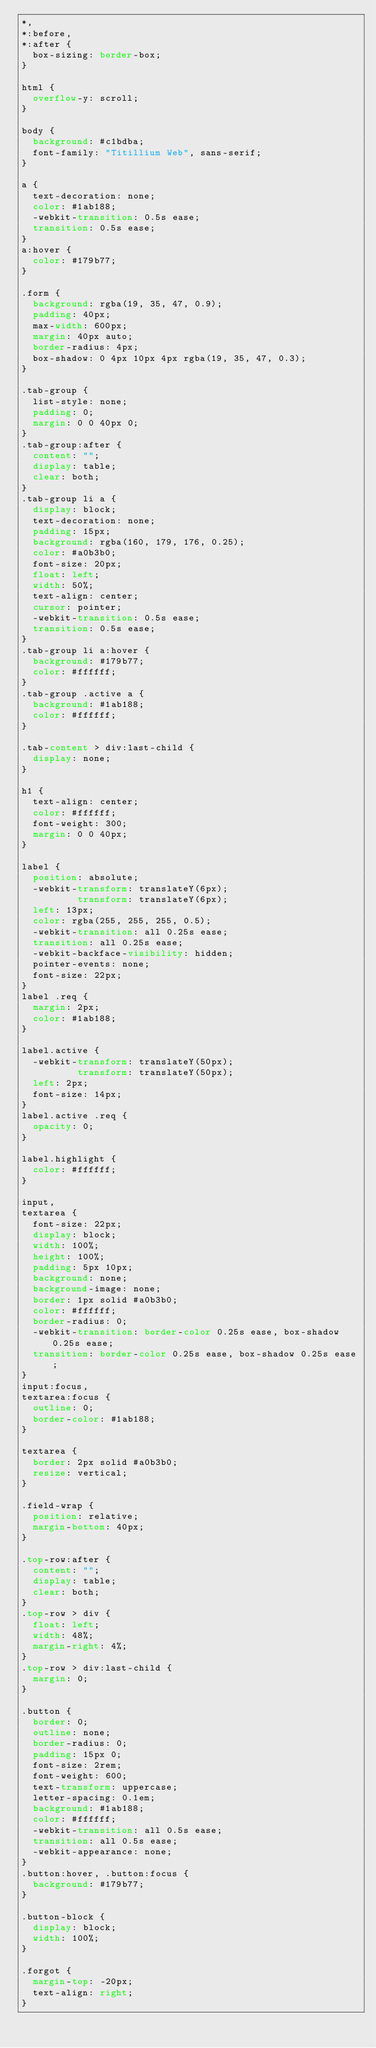Convert code to text. <code><loc_0><loc_0><loc_500><loc_500><_CSS_>*,
*:before,
*:after {
  box-sizing: border-box;
}

html {
  overflow-y: scroll;
}

body {
  background: #c1bdba;
  font-family: "Titillium Web", sans-serif;
}

a {
  text-decoration: none;
  color: #1ab188;
  -webkit-transition: 0.5s ease;
  transition: 0.5s ease;
}
a:hover {
  color: #179b77;
}

.form {
  background: rgba(19, 35, 47, 0.9);
  padding: 40px;
  max-width: 600px;
  margin: 40px auto;
  border-radius: 4px;
  box-shadow: 0 4px 10px 4px rgba(19, 35, 47, 0.3);
}

.tab-group {
  list-style: none;
  padding: 0;
  margin: 0 0 40px 0;
}
.tab-group:after {
  content: "";
  display: table;
  clear: both;
}
.tab-group li a {
  display: block;
  text-decoration: none;
  padding: 15px;
  background: rgba(160, 179, 176, 0.25);
  color: #a0b3b0;
  font-size: 20px;
  float: left;
  width: 50%;
  text-align: center;
  cursor: pointer;
  -webkit-transition: 0.5s ease;
  transition: 0.5s ease;
}
.tab-group li a:hover {
  background: #179b77;
  color: #ffffff;
}
.tab-group .active a {
  background: #1ab188;
  color: #ffffff;
}

.tab-content > div:last-child {
  display: none;
}

h1 {
  text-align: center;
  color: #ffffff;
  font-weight: 300;
  margin: 0 0 40px;
}

label {
  position: absolute;
  -webkit-transform: translateY(6px);
          transform: translateY(6px);
  left: 13px;
  color: rgba(255, 255, 255, 0.5);
  -webkit-transition: all 0.25s ease;
  transition: all 0.25s ease;
  -webkit-backface-visibility: hidden;
  pointer-events: none;
  font-size: 22px;
}
label .req {
  margin: 2px;
  color: #1ab188;
}

label.active {
  -webkit-transform: translateY(50px);
          transform: translateY(50px);
  left: 2px;
  font-size: 14px;
}
label.active .req {
  opacity: 0;
}

label.highlight {
  color: #ffffff;
}

input,
textarea {
  font-size: 22px;
  display: block;
  width: 100%;
  height: 100%;
  padding: 5px 10px;
  background: none;
  background-image: none;
  border: 1px solid #a0b3b0;
  color: #ffffff;
  border-radius: 0;
  -webkit-transition: border-color 0.25s ease, box-shadow 0.25s ease;
  transition: border-color 0.25s ease, box-shadow 0.25s ease;
}
input:focus,
textarea:focus {
  outline: 0;
  border-color: #1ab188;
}

textarea {
  border: 2px solid #a0b3b0;
  resize: vertical;
}

.field-wrap {
  position: relative;
  margin-bottom: 40px;
}

.top-row:after {
  content: "";
  display: table;
  clear: both;
}
.top-row > div {
  float: left;
  width: 48%;
  margin-right: 4%;
}
.top-row > div:last-child {
  margin: 0;
}

.button {
  border: 0;
  outline: none;
  border-radius: 0;
  padding: 15px 0;
  font-size: 2rem;
  font-weight: 600;
  text-transform: uppercase;
  letter-spacing: 0.1em;
  background: #1ab188;
  color: #ffffff;
  -webkit-transition: all 0.5s ease;
  transition: all 0.5s ease;
  -webkit-appearance: none;
}
.button:hover, .button:focus {
  background: #179b77;
}

.button-block {
  display: block;
  width: 100%;
}

.forgot {
  margin-top: -20px;
  text-align: right;
}</code> 